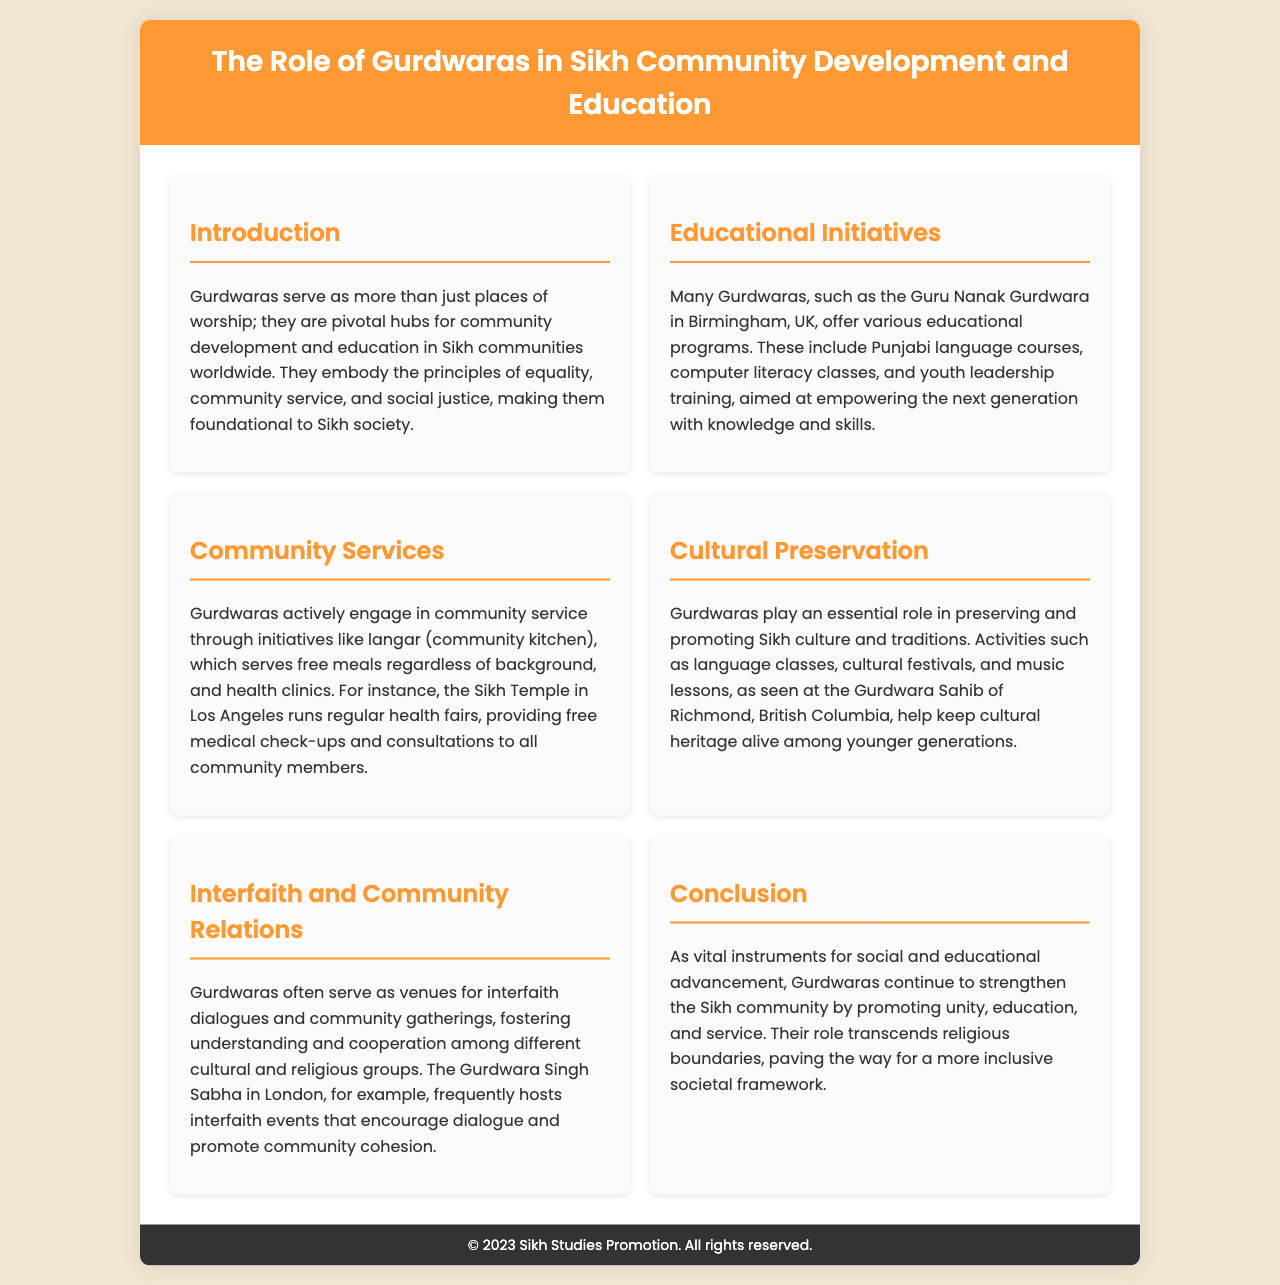What is the primary role of Gurdwaras? Gurdwaras serve as pivotal hubs for community development and education in Sikh communities worldwide.
Answer: Community development and education What type of classes does the Guru Nanak Gurdwara offer? The Guru Nanak Gurdwara offers Punjabi language courses and computer literacy classes.
Answer: Punjabi language courses, computer literacy classes What community service initiative is mentioned in the brochure? The brochure mentions langar, which serves free meals.
Answer: Langar Where is the Gurdwara Sahib that helps preserve Sikh culture located? The Gurdwara Sahib of Richmond, British Columbia is mentioned as a place that helps preserve Sikh culture.
Answer: Richmond, British Columbia What is one of the cultural activities supported by Gurdwaras? Gurdwaras support activities such as language classes.
Answer: Language classes What kind of events does the Gurdwara Singh Sabha host? The Gurdwara Singh Sabha frequently hosts interfaith events.
Answer: Interfaith events What is the underlying principle Gurdwaras embody in the Sikh community? Gurdwaras embody the principles of equality, community service, and social justice.
Answer: Equality, community service, social justice In what way do Gurdwaras contribute to youth development? They offer youth leadership training programs aimed at empowering the next generation.
Answer: Youth leadership training What year is mentioned in the footer of the brochure? The footer of the brochure indicates the year 2023.
Answer: 2023 